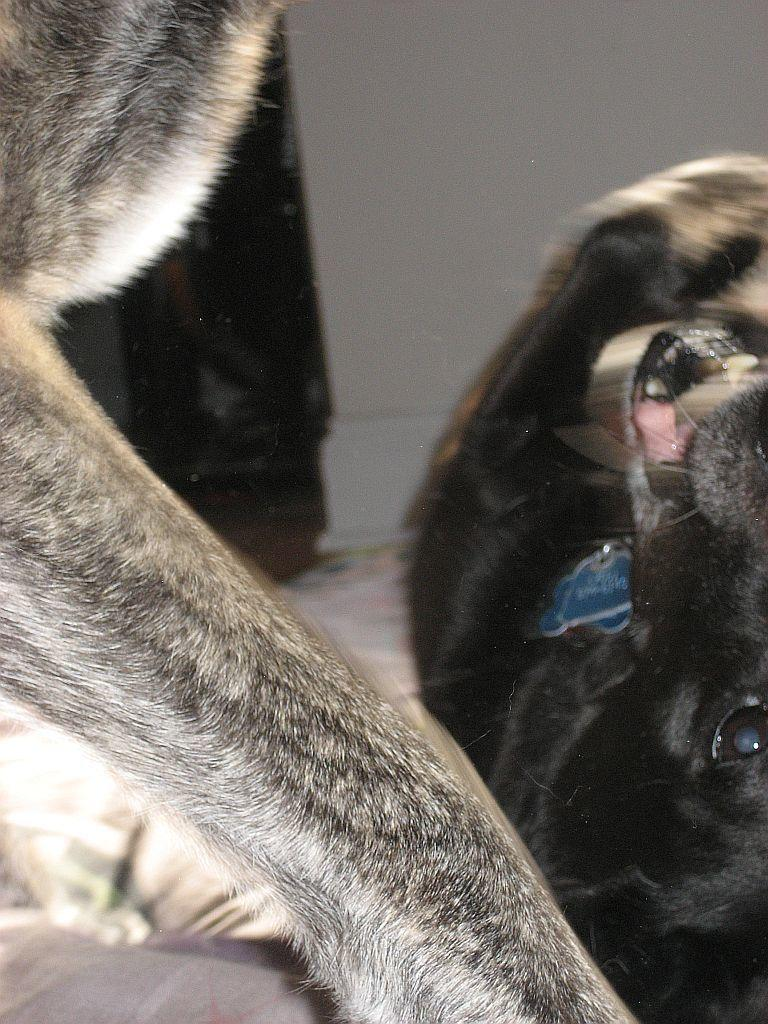What type of animal is present in the image? There is a dog in the image. Can you describe any other features related to the dog? There is a leg of another dog visible in the image. What type of store can be seen in the background of the image? There is no store present in the image; it only features a dog and a leg of another dog. What key is used to unlock the dog's collar in the image? There is no key or dog collar present in the image. 